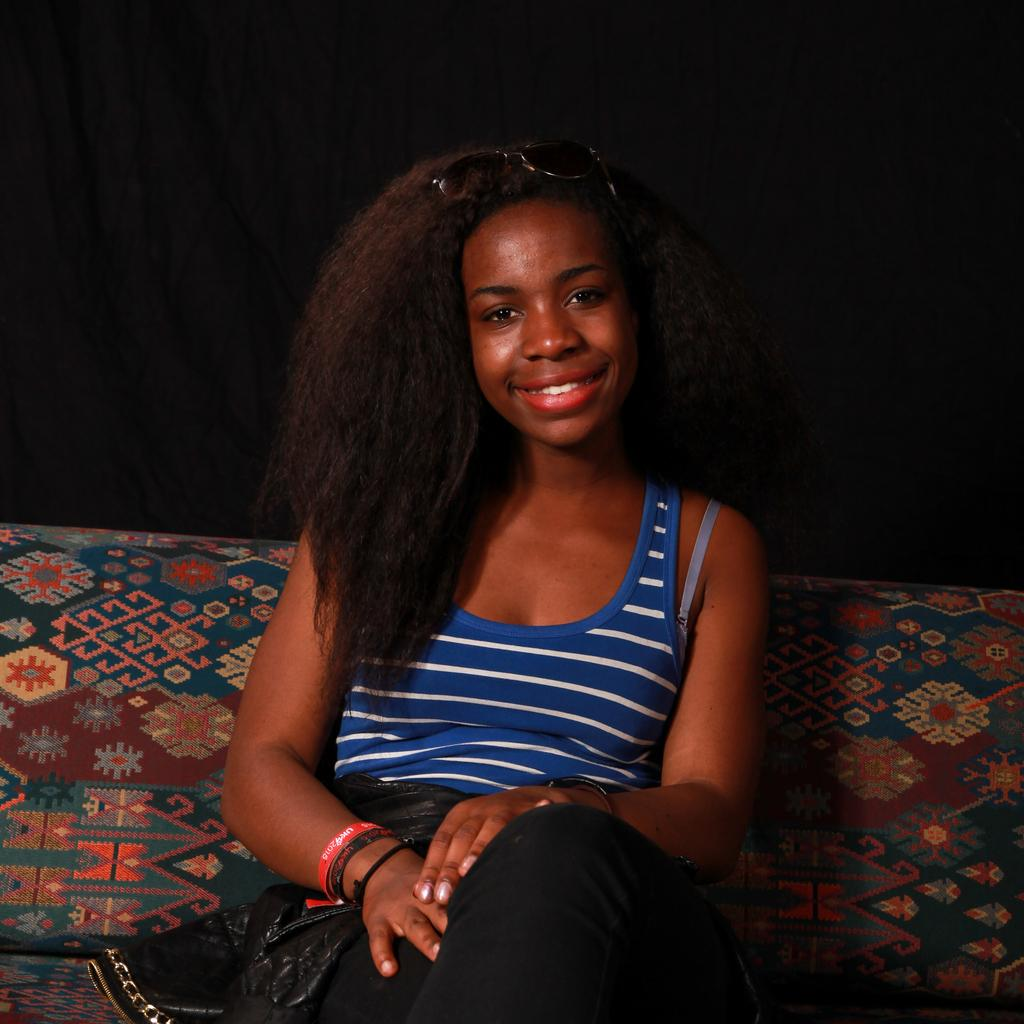Who is the main subject in the image? There is a woman in the image. What is the woman doing in the image? The woman is sitting. What expression does the woman have in the image? The woman is smiling. What can be observed about the background of the image? The background of the image is dark. What type of agreement is the woman signing in the image? There is no agreement or signing activity present in the image; the woman is simply sitting and smiling. 